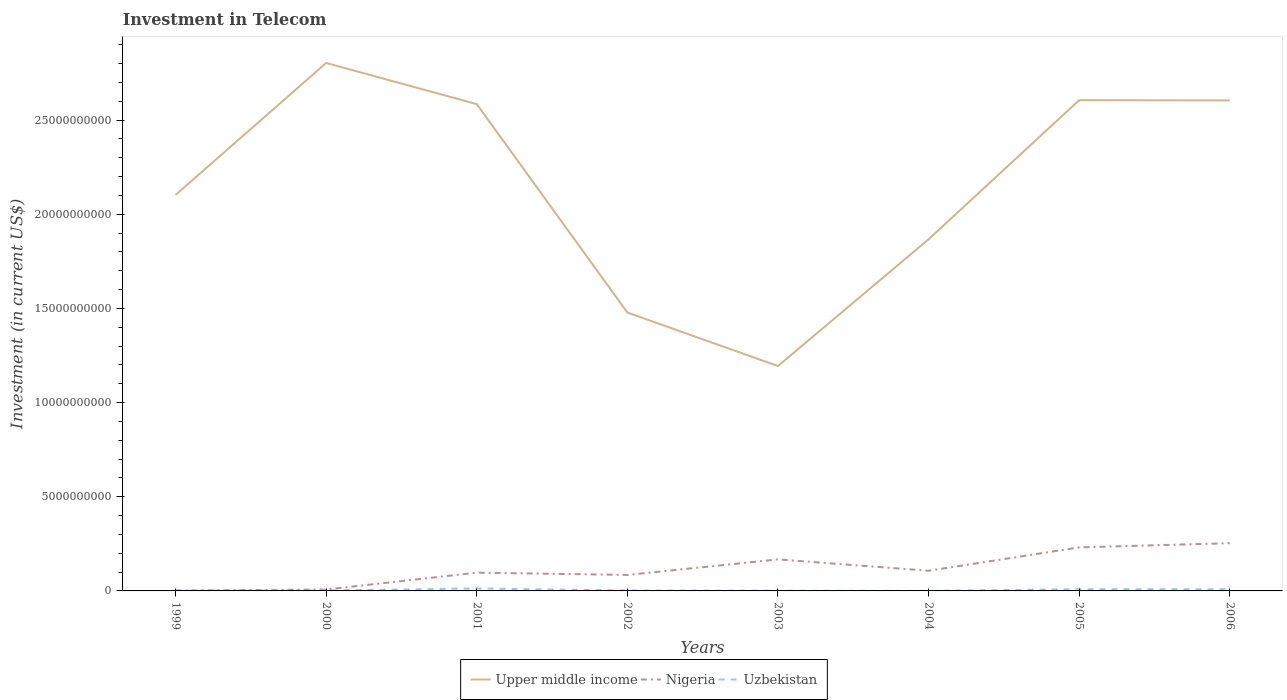How many different coloured lines are there?
Give a very brief answer. 3. Does the line corresponding to Upper middle income intersect with the line corresponding to Nigeria?
Your answer should be very brief. No. Is the number of lines equal to the number of legend labels?
Provide a short and direct response. Yes. Across all years, what is the maximum amount invested in telecom in Uzbekistan?
Offer a very short reply. 3.00e+06. What is the total amount invested in telecom in Upper middle income in the graph?
Your answer should be very brief. -4.82e+09. What is the difference between the highest and the second highest amount invested in telecom in Nigeria?
Keep it short and to the point. 2.52e+09. What is the difference between the highest and the lowest amount invested in telecom in Upper middle income?
Offer a very short reply. 4. Is the amount invested in telecom in Nigeria strictly greater than the amount invested in telecom in Upper middle income over the years?
Make the answer very short. Yes. How many lines are there?
Keep it short and to the point. 3. How many years are there in the graph?
Keep it short and to the point. 8. What is the difference between two consecutive major ticks on the Y-axis?
Give a very brief answer. 5.00e+09. Are the values on the major ticks of Y-axis written in scientific E-notation?
Keep it short and to the point. No. Does the graph contain any zero values?
Provide a succinct answer. No. How are the legend labels stacked?
Give a very brief answer. Horizontal. What is the title of the graph?
Offer a terse response. Investment in Telecom. Does "Vietnam" appear as one of the legend labels in the graph?
Give a very brief answer. No. What is the label or title of the Y-axis?
Provide a succinct answer. Investment (in current US$). What is the Investment (in current US$) of Upper middle income in 1999?
Your answer should be compact. 2.10e+1. What is the Investment (in current US$) in Nigeria in 1999?
Give a very brief answer. 1.90e+07. What is the Investment (in current US$) in Uzbekistan in 1999?
Provide a succinct answer. 1.32e+07. What is the Investment (in current US$) of Upper middle income in 2000?
Your answer should be compact. 2.80e+1. What is the Investment (in current US$) of Nigeria in 2000?
Your response must be concise. 7.57e+07. What is the Investment (in current US$) in Uzbekistan in 2000?
Offer a very short reply. 2.62e+07. What is the Investment (in current US$) of Upper middle income in 2001?
Offer a very short reply. 2.58e+1. What is the Investment (in current US$) in Nigeria in 2001?
Provide a succinct answer. 9.70e+08. What is the Investment (in current US$) in Uzbekistan in 2001?
Your response must be concise. 1.30e+08. What is the Investment (in current US$) in Upper middle income in 2002?
Give a very brief answer. 1.48e+1. What is the Investment (in current US$) in Nigeria in 2002?
Provide a succinct answer. 8.48e+08. What is the Investment (in current US$) of Uzbekistan in 2002?
Your answer should be very brief. 2.32e+07. What is the Investment (in current US$) in Upper middle income in 2003?
Make the answer very short. 1.19e+1. What is the Investment (in current US$) in Nigeria in 2003?
Your answer should be compact. 1.67e+09. What is the Investment (in current US$) of Upper middle income in 2004?
Offer a terse response. 1.87e+1. What is the Investment (in current US$) in Nigeria in 2004?
Your answer should be compact. 1.07e+09. What is the Investment (in current US$) in Uzbekistan in 2004?
Your response must be concise. 3.00e+06. What is the Investment (in current US$) of Upper middle income in 2005?
Make the answer very short. 2.61e+1. What is the Investment (in current US$) of Nigeria in 2005?
Provide a short and direct response. 2.31e+09. What is the Investment (in current US$) in Uzbekistan in 2005?
Provide a succinct answer. 9.30e+07. What is the Investment (in current US$) in Upper middle income in 2006?
Provide a succinct answer. 2.60e+1. What is the Investment (in current US$) in Nigeria in 2006?
Your answer should be very brief. 2.54e+09. What is the Investment (in current US$) in Uzbekistan in 2006?
Offer a terse response. 9.00e+07. Across all years, what is the maximum Investment (in current US$) in Upper middle income?
Provide a short and direct response. 2.80e+1. Across all years, what is the maximum Investment (in current US$) in Nigeria?
Keep it short and to the point. 2.54e+09. Across all years, what is the maximum Investment (in current US$) in Uzbekistan?
Make the answer very short. 1.30e+08. Across all years, what is the minimum Investment (in current US$) in Upper middle income?
Your response must be concise. 1.19e+1. Across all years, what is the minimum Investment (in current US$) of Nigeria?
Make the answer very short. 1.90e+07. What is the total Investment (in current US$) of Upper middle income in the graph?
Keep it short and to the point. 1.72e+11. What is the total Investment (in current US$) in Nigeria in the graph?
Offer a terse response. 9.50e+09. What is the total Investment (in current US$) in Uzbekistan in the graph?
Ensure brevity in your answer.  3.89e+08. What is the difference between the Investment (in current US$) of Upper middle income in 1999 and that in 2000?
Offer a terse response. -7.00e+09. What is the difference between the Investment (in current US$) of Nigeria in 1999 and that in 2000?
Give a very brief answer. -5.67e+07. What is the difference between the Investment (in current US$) of Uzbekistan in 1999 and that in 2000?
Provide a succinct answer. -1.30e+07. What is the difference between the Investment (in current US$) in Upper middle income in 1999 and that in 2001?
Offer a terse response. -4.82e+09. What is the difference between the Investment (in current US$) in Nigeria in 1999 and that in 2001?
Ensure brevity in your answer.  -9.51e+08. What is the difference between the Investment (in current US$) in Uzbekistan in 1999 and that in 2001?
Provide a succinct answer. -1.17e+08. What is the difference between the Investment (in current US$) in Upper middle income in 1999 and that in 2002?
Your answer should be very brief. 6.25e+09. What is the difference between the Investment (in current US$) in Nigeria in 1999 and that in 2002?
Your answer should be compact. -8.29e+08. What is the difference between the Investment (in current US$) of Uzbekistan in 1999 and that in 2002?
Give a very brief answer. -1.00e+07. What is the difference between the Investment (in current US$) in Upper middle income in 1999 and that in 2003?
Provide a short and direct response. 9.09e+09. What is the difference between the Investment (in current US$) in Nigeria in 1999 and that in 2003?
Your answer should be very brief. -1.66e+09. What is the difference between the Investment (in current US$) of Uzbekistan in 1999 and that in 2003?
Provide a succinct answer. 3.20e+06. What is the difference between the Investment (in current US$) of Upper middle income in 1999 and that in 2004?
Your response must be concise. 2.36e+09. What is the difference between the Investment (in current US$) of Nigeria in 1999 and that in 2004?
Offer a very short reply. -1.05e+09. What is the difference between the Investment (in current US$) of Uzbekistan in 1999 and that in 2004?
Offer a very short reply. 1.02e+07. What is the difference between the Investment (in current US$) of Upper middle income in 1999 and that in 2005?
Provide a short and direct response. -5.03e+09. What is the difference between the Investment (in current US$) in Nigeria in 1999 and that in 2005?
Offer a very short reply. -2.29e+09. What is the difference between the Investment (in current US$) of Uzbekistan in 1999 and that in 2005?
Make the answer very short. -7.98e+07. What is the difference between the Investment (in current US$) of Upper middle income in 1999 and that in 2006?
Your answer should be very brief. -5.02e+09. What is the difference between the Investment (in current US$) in Nigeria in 1999 and that in 2006?
Ensure brevity in your answer.  -2.52e+09. What is the difference between the Investment (in current US$) of Uzbekistan in 1999 and that in 2006?
Provide a short and direct response. -7.68e+07. What is the difference between the Investment (in current US$) in Upper middle income in 2000 and that in 2001?
Provide a succinct answer. 2.18e+09. What is the difference between the Investment (in current US$) of Nigeria in 2000 and that in 2001?
Make the answer very short. -8.94e+08. What is the difference between the Investment (in current US$) in Uzbekistan in 2000 and that in 2001?
Provide a short and direct response. -1.04e+08. What is the difference between the Investment (in current US$) of Upper middle income in 2000 and that in 2002?
Make the answer very short. 1.33e+1. What is the difference between the Investment (in current US$) of Nigeria in 2000 and that in 2002?
Make the answer very short. -7.72e+08. What is the difference between the Investment (in current US$) of Upper middle income in 2000 and that in 2003?
Offer a very short reply. 1.61e+1. What is the difference between the Investment (in current US$) in Nigeria in 2000 and that in 2003?
Your response must be concise. -1.60e+09. What is the difference between the Investment (in current US$) of Uzbekistan in 2000 and that in 2003?
Offer a terse response. 1.62e+07. What is the difference between the Investment (in current US$) in Upper middle income in 2000 and that in 2004?
Keep it short and to the point. 9.36e+09. What is the difference between the Investment (in current US$) in Nigeria in 2000 and that in 2004?
Offer a very short reply. -9.94e+08. What is the difference between the Investment (in current US$) in Uzbekistan in 2000 and that in 2004?
Your answer should be compact. 2.32e+07. What is the difference between the Investment (in current US$) of Upper middle income in 2000 and that in 2005?
Offer a very short reply. 1.98e+09. What is the difference between the Investment (in current US$) of Nigeria in 2000 and that in 2005?
Your response must be concise. -2.24e+09. What is the difference between the Investment (in current US$) in Uzbekistan in 2000 and that in 2005?
Make the answer very short. -6.68e+07. What is the difference between the Investment (in current US$) of Upper middle income in 2000 and that in 2006?
Offer a terse response. 1.99e+09. What is the difference between the Investment (in current US$) of Nigeria in 2000 and that in 2006?
Make the answer very short. -2.46e+09. What is the difference between the Investment (in current US$) in Uzbekistan in 2000 and that in 2006?
Your answer should be compact. -6.38e+07. What is the difference between the Investment (in current US$) of Upper middle income in 2001 and that in 2002?
Your answer should be very brief. 1.11e+1. What is the difference between the Investment (in current US$) in Nigeria in 2001 and that in 2002?
Your answer should be very brief. 1.22e+08. What is the difference between the Investment (in current US$) of Uzbekistan in 2001 and that in 2002?
Ensure brevity in your answer.  1.07e+08. What is the difference between the Investment (in current US$) of Upper middle income in 2001 and that in 2003?
Your answer should be compact. 1.39e+1. What is the difference between the Investment (in current US$) of Nigeria in 2001 and that in 2003?
Offer a terse response. -7.04e+08. What is the difference between the Investment (in current US$) in Uzbekistan in 2001 and that in 2003?
Keep it short and to the point. 1.20e+08. What is the difference between the Investment (in current US$) of Upper middle income in 2001 and that in 2004?
Give a very brief answer. 7.18e+09. What is the difference between the Investment (in current US$) of Nigeria in 2001 and that in 2004?
Your answer should be compact. -1.00e+08. What is the difference between the Investment (in current US$) in Uzbekistan in 2001 and that in 2004?
Offer a very short reply. 1.27e+08. What is the difference between the Investment (in current US$) in Upper middle income in 2001 and that in 2005?
Offer a terse response. -2.09e+08. What is the difference between the Investment (in current US$) of Nigeria in 2001 and that in 2005?
Keep it short and to the point. -1.34e+09. What is the difference between the Investment (in current US$) in Uzbekistan in 2001 and that in 2005?
Provide a succinct answer. 3.72e+07. What is the difference between the Investment (in current US$) of Upper middle income in 2001 and that in 2006?
Keep it short and to the point. -1.96e+08. What is the difference between the Investment (in current US$) in Nigeria in 2001 and that in 2006?
Your answer should be compact. -1.57e+09. What is the difference between the Investment (in current US$) in Uzbekistan in 2001 and that in 2006?
Your answer should be compact. 4.02e+07. What is the difference between the Investment (in current US$) of Upper middle income in 2002 and that in 2003?
Your answer should be compact. 2.84e+09. What is the difference between the Investment (in current US$) in Nigeria in 2002 and that in 2003?
Your answer should be very brief. -8.26e+08. What is the difference between the Investment (in current US$) in Uzbekistan in 2002 and that in 2003?
Your answer should be very brief. 1.32e+07. What is the difference between the Investment (in current US$) of Upper middle income in 2002 and that in 2004?
Your response must be concise. -3.89e+09. What is the difference between the Investment (in current US$) in Nigeria in 2002 and that in 2004?
Your answer should be compact. -2.22e+08. What is the difference between the Investment (in current US$) in Uzbekistan in 2002 and that in 2004?
Give a very brief answer. 2.02e+07. What is the difference between the Investment (in current US$) of Upper middle income in 2002 and that in 2005?
Your response must be concise. -1.13e+1. What is the difference between the Investment (in current US$) in Nigeria in 2002 and that in 2005?
Your response must be concise. -1.46e+09. What is the difference between the Investment (in current US$) of Uzbekistan in 2002 and that in 2005?
Your response must be concise. -6.98e+07. What is the difference between the Investment (in current US$) of Upper middle income in 2002 and that in 2006?
Your answer should be very brief. -1.13e+1. What is the difference between the Investment (in current US$) of Nigeria in 2002 and that in 2006?
Ensure brevity in your answer.  -1.69e+09. What is the difference between the Investment (in current US$) in Uzbekistan in 2002 and that in 2006?
Make the answer very short. -6.68e+07. What is the difference between the Investment (in current US$) in Upper middle income in 2003 and that in 2004?
Your response must be concise. -6.73e+09. What is the difference between the Investment (in current US$) in Nigeria in 2003 and that in 2004?
Keep it short and to the point. 6.04e+08. What is the difference between the Investment (in current US$) in Uzbekistan in 2003 and that in 2004?
Your response must be concise. 7.00e+06. What is the difference between the Investment (in current US$) in Upper middle income in 2003 and that in 2005?
Offer a very short reply. -1.41e+1. What is the difference between the Investment (in current US$) in Nigeria in 2003 and that in 2005?
Give a very brief answer. -6.38e+08. What is the difference between the Investment (in current US$) of Uzbekistan in 2003 and that in 2005?
Make the answer very short. -8.30e+07. What is the difference between the Investment (in current US$) in Upper middle income in 2003 and that in 2006?
Offer a very short reply. -1.41e+1. What is the difference between the Investment (in current US$) in Nigeria in 2003 and that in 2006?
Your answer should be compact. -8.61e+08. What is the difference between the Investment (in current US$) in Uzbekistan in 2003 and that in 2006?
Offer a very short reply. -8.00e+07. What is the difference between the Investment (in current US$) of Upper middle income in 2004 and that in 2005?
Keep it short and to the point. -7.39e+09. What is the difference between the Investment (in current US$) of Nigeria in 2004 and that in 2005?
Provide a succinct answer. -1.24e+09. What is the difference between the Investment (in current US$) of Uzbekistan in 2004 and that in 2005?
Your response must be concise. -9.00e+07. What is the difference between the Investment (in current US$) in Upper middle income in 2004 and that in 2006?
Offer a very short reply. -7.37e+09. What is the difference between the Investment (in current US$) of Nigeria in 2004 and that in 2006?
Ensure brevity in your answer.  -1.47e+09. What is the difference between the Investment (in current US$) in Uzbekistan in 2004 and that in 2006?
Provide a short and direct response. -8.70e+07. What is the difference between the Investment (in current US$) in Upper middle income in 2005 and that in 2006?
Keep it short and to the point. 1.27e+07. What is the difference between the Investment (in current US$) of Nigeria in 2005 and that in 2006?
Provide a short and direct response. -2.23e+08. What is the difference between the Investment (in current US$) of Uzbekistan in 2005 and that in 2006?
Ensure brevity in your answer.  3.00e+06. What is the difference between the Investment (in current US$) in Upper middle income in 1999 and the Investment (in current US$) in Nigeria in 2000?
Your answer should be very brief. 2.10e+1. What is the difference between the Investment (in current US$) in Upper middle income in 1999 and the Investment (in current US$) in Uzbekistan in 2000?
Make the answer very short. 2.10e+1. What is the difference between the Investment (in current US$) in Nigeria in 1999 and the Investment (in current US$) in Uzbekistan in 2000?
Offer a very short reply. -7.20e+06. What is the difference between the Investment (in current US$) of Upper middle income in 1999 and the Investment (in current US$) of Nigeria in 2001?
Your answer should be very brief. 2.01e+1. What is the difference between the Investment (in current US$) in Upper middle income in 1999 and the Investment (in current US$) in Uzbekistan in 2001?
Ensure brevity in your answer.  2.09e+1. What is the difference between the Investment (in current US$) of Nigeria in 1999 and the Investment (in current US$) of Uzbekistan in 2001?
Provide a succinct answer. -1.11e+08. What is the difference between the Investment (in current US$) of Upper middle income in 1999 and the Investment (in current US$) of Nigeria in 2002?
Give a very brief answer. 2.02e+1. What is the difference between the Investment (in current US$) in Upper middle income in 1999 and the Investment (in current US$) in Uzbekistan in 2002?
Your answer should be very brief. 2.10e+1. What is the difference between the Investment (in current US$) of Nigeria in 1999 and the Investment (in current US$) of Uzbekistan in 2002?
Give a very brief answer. -4.20e+06. What is the difference between the Investment (in current US$) in Upper middle income in 1999 and the Investment (in current US$) in Nigeria in 2003?
Your response must be concise. 1.94e+1. What is the difference between the Investment (in current US$) in Upper middle income in 1999 and the Investment (in current US$) in Uzbekistan in 2003?
Offer a very short reply. 2.10e+1. What is the difference between the Investment (in current US$) in Nigeria in 1999 and the Investment (in current US$) in Uzbekistan in 2003?
Make the answer very short. 9.00e+06. What is the difference between the Investment (in current US$) of Upper middle income in 1999 and the Investment (in current US$) of Nigeria in 2004?
Give a very brief answer. 2.00e+1. What is the difference between the Investment (in current US$) of Upper middle income in 1999 and the Investment (in current US$) of Uzbekistan in 2004?
Provide a succinct answer. 2.10e+1. What is the difference between the Investment (in current US$) of Nigeria in 1999 and the Investment (in current US$) of Uzbekistan in 2004?
Make the answer very short. 1.60e+07. What is the difference between the Investment (in current US$) of Upper middle income in 1999 and the Investment (in current US$) of Nigeria in 2005?
Provide a succinct answer. 1.87e+1. What is the difference between the Investment (in current US$) of Upper middle income in 1999 and the Investment (in current US$) of Uzbekistan in 2005?
Offer a terse response. 2.09e+1. What is the difference between the Investment (in current US$) in Nigeria in 1999 and the Investment (in current US$) in Uzbekistan in 2005?
Your response must be concise. -7.40e+07. What is the difference between the Investment (in current US$) in Upper middle income in 1999 and the Investment (in current US$) in Nigeria in 2006?
Make the answer very short. 1.85e+1. What is the difference between the Investment (in current US$) in Upper middle income in 1999 and the Investment (in current US$) in Uzbekistan in 2006?
Offer a terse response. 2.09e+1. What is the difference between the Investment (in current US$) in Nigeria in 1999 and the Investment (in current US$) in Uzbekistan in 2006?
Offer a very short reply. -7.10e+07. What is the difference between the Investment (in current US$) in Upper middle income in 2000 and the Investment (in current US$) in Nigeria in 2001?
Your answer should be very brief. 2.71e+1. What is the difference between the Investment (in current US$) of Upper middle income in 2000 and the Investment (in current US$) of Uzbekistan in 2001?
Offer a terse response. 2.79e+1. What is the difference between the Investment (in current US$) in Nigeria in 2000 and the Investment (in current US$) in Uzbekistan in 2001?
Provide a succinct answer. -5.45e+07. What is the difference between the Investment (in current US$) in Upper middle income in 2000 and the Investment (in current US$) in Nigeria in 2002?
Keep it short and to the point. 2.72e+1. What is the difference between the Investment (in current US$) of Upper middle income in 2000 and the Investment (in current US$) of Uzbekistan in 2002?
Provide a short and direct response. 2.80e+1. What is the difference between the Investment (in current US$) in Nigeria in 2000 and the Investment (in current US$) in Uzbekistan in 2002?
Make the answer very short. 5.25e+07. What is the difference between the Investment (in current US$) of Upper middle income in 2000 and the Investment (in current US$) of Nigeria in 2003?
Give a very brief answer. 2.64e+1. What is the difference between the Investment (in current US$) in Upper middle income in 2000 and the Investment (in current US$) in Uzbekistan in 2003?
Keep it short and to the point. 2.80e+1. What is the difference between the Investment (in current US$) of Nigeria in 2000 and the Investment (in current US$) of Uzbekistan in 2003?
Your response must be concise. 6.57e+07. What is the difference between the Investment (in current US$) of Upper middle income in 2000 and the Investment (in current US$) of Nigeria in 2004?
Ensure brevity in your answer.  2.70e+1. What is the difference between the Investment (in current US$) in Upper middle income in 2000 and the Investment (in current US$) in Uzbekistan in 2004?
Your answer should be compact. 2.80e+1. What is the difference between the Investment (in current US$) in Nigeria in 2000 and the Investment (in current US$) in Uzbekistan in 2004?
Offer a terse response. 7.27e+07. What is the difference between the Investment (in current US$) of Upper middle income in 2000 and the Investment (in current US$) of Nigeria in 2005?
Give a very brief answer. 2.57e+1. What is the difference between the Investment (in current US$) in Upper middle income in 2000 and the Investment (in current US$) in Uzbekistan in 2005?
Your answer should be compact. 2.79e+1. What is the difference between the Investment (in current US$) in Nigeria in 2000 and the Investment (in current US$) in Uzbekistan in 2005?
Ensure brevity in your answer.  -1.73e+07. What is the difference between the Investment (in current US$) of Upper middle income in 2000 and the Investment (in current US$) of Nigeria in 2006?
Offer a terse response. 2.55e+1. What is the difference between the Investment (in current US$) in Upper middle income in 2000 and the Investment (in current US$) in Uzbekistan in 2006?
Your answer should be compact. 2.79e+1. What is the difference between the Investment (in current US$) of Nigeria in 2000 and the Investment (in current US$) of Uzbekistan in 2006?
Your response must be concise. -1.43e+07. What is the difference between the Investment (in current US$) of Upper middle income in 2001 and the Investment (in current US$) of Nigeria in 2002?
Give a very brief answer. 2.50e+1. What is the difference between the Investment (in current US$) in Upper middle income in 2001 and the Investment (in current US$) in Uzbekistan in 2002?
Offer a terse response. 2.58e+1. What is the difference between the Investment (in current US$) of Nigeria in 2001 and the Investment (in current US$) of Uzbekistan in 2002?
Ensure brevity in your answer.  9.47e+08. What is the difference between the Investment (in current US$) of Upper middle income in 2001 and the Investment (in current US$) of Nigeria in 2003?
Your answer should be compact. 2.42e+1. What is the difference between the Investment (in current US$) of Upper middle income in 2001 and the Investment (in current US$) of Uzbekistan in 2003?
Your answer should be compact. 2.58e+1. What is the difference between the Investment (in current US$) of Nigeria in 2001 and the Investment (in current US$) of Uzbekistan in 2003?
Offer a very short reply. 9.60e+08. What is the difference between the Investment (in current US$) in Upper middle income in 2001 and the Investment (in current US$) in Nigeria in 2004?
Offer a terse response. 2.48e+1. What is the difference between the Investment (in current US$) in Upper middle income in 2001 and the Investment (in current US$) in Uzbekistan in 2004?
Offer a very short reply. 2.58e+1. What is the difference between the Investment (in current US$) in Nigeria in 2001 and the Investment (in current US$) in Uzbekistan in 2004?
Make the answer very short. 9.67e+08. What is the difference between the Investment (in current US$) of Upper middle income in 2001 and the Investment (in current US$) of Nigeria in 2005?
Your response must be concise. 2.35e+1. What is the difference between the Investment (in current US$) of Upper middle income in 2001 and the Investment (in current US$) of Uzbekistan in 2005?
Your response must be concise. 2.58e+1. What is the difference between the Investment (in current US$) in Nigeria in 2001 and the Investment (in current US$) in Uzbekistan in 2005?
Offer a terse response. 8.77e+08. What is the difference between the Investment (in current US$) in Upper middle income in 2001 and the Investment (in current US$) in Nigeria in 2006?
Your answer should be compact. 2.33e+1. What is the difference between the Investment (in current US$) in Upper middle income in 2001 and the Investment (in current US$) in Uzbekistan in 2006?
Your response must be concise. 2.58e+1. What is the difference between the Investment (in current US$) of Nigeria in 2001 and the Investment (in current US$) of Uzbekistan in 2006?
Your response must be concise. 8.80e+08. What is the difference between the Investment (in current US$) in Upper middle income in 2002 and the Investment (in current US$) in Nigeria in 2003?
Offer a terse response. 1.31e+1. What is the difference between the Investment (in current US$) of Upper middle income in 2002 and the Investment (in current US$) of Uzbekistan in 2003?
Your answer should be very brief. 1.48e+1. What is the difference between the Investment (in current US$) of Nigeria in 2002 and the Investment (in current US$) of Uzbekistan in 2003?
Keep it short and to the point. 8.38e+08. What is the difference between the Investment (in current US$) of Upper middle income in 2002 and the Investment (in current US$) of Nigeria in 2004?
Offer a terse response. 1.37e+1. What is the difference between the Investment (in current US$) of Upper middle income in 2002 and the Investment (in current US$) of Uzbekistan in 2004?
Keep it short and to the point. 1.48e+1. What is the difference between the Investment (in current US$) in Nigeria in 2002 and the Investment (in current US$) in Uzbekistan in 2004?
Give a very brief answer. 8.45e+08. What is the difference between the Investment (in current US$) of Upper middle income in 2002 and the Investment (in current US$) of Nigeria in 2005?
Keep it short and to the point. 1.25e+1. What is the difference between the Investment (in current US$) in Upper middle income in 2002 and the Investment (in current US$) in Uzbekistan in 2005?
Make the answer very short. 1.47e+1. What is the difference between the Investment (in current US$) in Nigeria in 2002 and the Investment (in current US$) in Uzbekistan in 2005?
Your answer should be very brief. 7.55e+08. What is the difference between the Investment (in current US$) in Upper middle income in 2002 and the Investment (in current US$) in Nigeria in 2006?
Provide a succinct answer. 1.22e+1. What is the difference between the Investment (in current US$) of Upper middle income in 2002 and the Investment (in current US$) of Uzbekistan in 2006?
Your answer should be compact. 1.47e+1. What is the difference between the Investment (in current US$) in Nigeria in 2002 and the Investment (in current US$) in Uzbekistan in 2006?
Give a very brief answer. 7.58e+08. What is the difference between the Investment (in current US$) of Upper middle income in 2003 and the Investment (in current US$) of Nigeria in 2004?
Provide a short and direct response. 1.09e+1. What is the difference between the Investment (in current US$) of Upper middle income in 2003 and the Investment (in current US$) of Uzbekistan in 2004?
Keep it short and to the point. 1.19e+1. What is the difference between the Investment (in current US$) of Nigeria in 2003 and the Investment (in current US$) of Uzbekistan in 2004?
Offer a terse response. 1.67e+09. What is the difference between the Investment (in current US$) of Upper middle income in 2003 and the Investment (in current US$) of Nigeria in 2005?
Your response must be concise. 9.63e+09. What is the difference between the Investment (in current US$) of Upper middle income in 2003 and the Investment (in current US$) of Uzbekistan in 2005?
Your response must be concise. 1.18e+1. What is the difference between the Investment (in current US$) of Nigeria in 2003 and the Investment (in current US$) of Uzbekistan in 2005?
Offer a very short reply. 1.58e+09. What is the difference between the Investment (in current US$) of Upper middle income in 2003 and the Investment (in current US$) of Nigeria in 2006?
Your answer should be compact. 9.41e+09. What is the difference between the Investment (in current US$) in Upper middle income in 2003 and the Investment (in current US$) in Uzbekistan in 2006?
Provide a short and direct response. 1.19e+1. What is the difference between the Investment (in current US$) of Nigeria in 2003 and the Investment (in current US$) of Uzbekistan in 2006?
Ensure brevity in your answer.  1.58e+09. What is the difference between the Investment (in current US$) of Upper middle income in 2004 and the Investment (in current US$) of Nigeria in 2005?
Provide a short and direct response. 1.64e+1. What is the difference between the Investment (in current US$) of Upper middle income in 2004 and the Investment (in current US$) of Uzbekistan in 2005?
Make the answer very short. 1.86e+1. What is the difference between the Investment (in current US$) in Nigeria in 2004 and the Investment (in current US$) in Uzbekistan in 2005?
Your answer should be compact. 9.77e+08. What is the difference between the Investment (in current US$) of Upper middle income in 2004 and the Investment (in current US$) of Nigeria in 2006?
Your answer should be very brief. 1.61e+1. What is the difference between the Investment (in current US$) in Upper middle income in 2004 and the Investment (in current US$) in Uzbekistan in 2006?
Keep it short and to the point. 1.86e+1. What is the difference between the Investment (in current US$) in Nigeria in 2004 and the Investment (in current US$) in Uzbekistan in 2006?
Provide a short and direct response. 9.80e+08. What is the difference between the Investment (in current US$) of Upper middle income in 2005 and the Investment (in current US$) of Nigeria in 2006?
Keep it short and to the point. 2.35e+1. What is the difference between the Investment (in current US$) in Upper middle income in 2005 and the Investment (in current US$) in Uzbekistan in 2006?
Your answer should be compact. 2.60e+1. What is the difference between the Investment (in current US$) of Nigeria in 2005 and the Investment (in current US$) of Uzbekistan in 2006?
Ensure brevity in your answer.  2.22e+09. What is the average Investment (in current US$) of Upper middle income per year?
Give a very brief answer. 2.15e+1. What is the average Investment (in current US$) of Nigeria per year?
Your answer should be very brief. 1.19e+09. What is the average Investment (in current US$) in Uzbekistan per year?
Keep it short and to the point. 4.86e+07. In the year 1999, what is the difference between the Investment (in current US$) in Upper middle income and Investment (in current US$) in Nigeria?
Make the answer very short. 2.10e+1. In the year 1999, what is the difference between the Investment (in current US$) in Upper middle income and Investment (in current US$) in Uzbekistan?
Offer a very short reply. 2.10e+1. In the year 1999, what is the difference between the Investment (in current US$) in Nigeria and Investment (in current US$) in Uzbekistan?
Offer a very short reply. 5.80e+06. In the year 2000, what is the difference between the Investment (in current US$) of Upper middle income and Investment (in current US$) of Nigeria?
Your answer should be very brief. 2.80e+1. In the year 2000, what is the difference between the Investment (in current US$) in Upper middle income and Investment (in current US$) in Uzbekistan?
Provide a short and direct response. 2.80e+1. In the year 2000, what is the difference between the Investment (in current US$) in Nigeria and Investment (in current US$) in Uzbekistan?
Make the answer very short. 4.95e+07. In the year 2001, what is the difference between the Investment (in current US$) of Upper middle income and Investment (in current US$) of Nigeria?
Provide a succinct answer. 2.49e+1. In the year 2001, what is the difference between the Investment (in current US$) in Upper middle income and Investment (in current US$) in Uzbekistan?
Offer a very short reply. 2.57e+1. In the year 2001, what is the difference between the Investment (in current US$) of Nigeria and Investment (in current US$) of Uzbekistan?
Your response must be concise. 8.40e+08. In the year 2002, what is the difference between the Investment (in current US$) in Upper middle income and Investment (in current US$) in Nigeria?
Ensure brevity in your answer.  1.39e+1. In the year 2002, what is the difference between the Investment (in current US$) in Upper middle income and Investment (in current US$) in Uzbekistan?
Keep it short and to the point. 1.48e+1. In the year 2002, what is the difference between the Investment (in current US$) of Nigeria and Investment (in current US$) of Uzbekistan?
Ensure brevity in your answer.  8.25e+08. In the year 2003, what is the difference between the Investment (in current US$) in Upper middle income and Investment (in current US$) in Nigeria?
Ensure brevity in your answer.  1.03e+1. In the year 2003, what is the difference between the Investment (in current US$) of Upper middle income and Investment (in current US$) of Uzbekistan?
Make the answer very short. 1.19e+1. In the year 2003, what is the difference between the Investment (in current US$) in Nigeria and Investment (in current US$) in Uzbekistan?
Your response must be concise. 1.66e+09. In the year 2004, what is the difference between the Investment (in current US$) in Upper middle income and Investment (in current US$) in Nigeria?
Provide a short and direct response. 1.76e+1. In the year 2004, what is the difference between the Investment (in current US$) in Upper middle income and Investment (in current US$) in Uzbekistan?
Provide a short and direct response. 1.87e+1. In the year 2004, what is the difference between the Investment (in current US$) of Nigeria and Investment (in current US$) of Uzbekistan?
Give a very brief answer. 1.07e+09. In the year 2005, what is the difference between the Investment (in current US$) in Upper middle income and Investment (in current US$) in Nigeria?
Offer a terse response. 2.37e+1. In the year 2005, what is the difference between the Investment (in current US$) of Upper middle income and Investment (in current US$) of Uzbekistan?
Keep it short and to the point. 2.60e+1. In the year 2005, what is the difference between the Investment (in current US$) in Nigeria and Investment (in current US$) in Uzbekistan?
Your answer should be compact. 2.22e+09. In the year 2006, what is the difference between the Investment (in current US$) in Upper middle income and Investment (in current US$) in Nigeria?
Your response must be concise. 2.35e+1. In the year 2006, what is the difference between the Investment (in current US$) in Upper middle income and Investment (in current US$) in Uzbekistan?
Provide a short and direct response. 2.60e+1. In the year 2006, what is the difference between the Investment (in current US$) of Nigeria and Investment (in current US$) of Uzbekistan?
Your answer should be compact. 2.45e+09. What is the ratio of the Investment (in current US$) of Upper middle income in 1999 to that in 2000?
Your answer should be compact. 0.75. What is the ratio of the Investment (in current US$) of Nigeria in 1999 to that in 2000?
Your response must be concise. 0.25. What is the ratio of the Investment (in current US$) in Uzbekistan in 1999 to that in 2000?
Offer a very short reply. 0.5. What is the ratio of the Investment (in current US$) of Upper middle income in 1999 to that in 2001?
Your response must be concise. 0.81. What is the ratio of the Investment (in current US$) in Nigeria in 1999 to that in 2001?
Provide a short and direct response. 0.02. What is the ratio of the Investment (in current US$) of Uzbekistan in 1999 to that in 2001?
Provide a short and direct response. 0.1. What is the ratio of the Investment (in current US$) of Upper middle income in 1999 to that in 2002?
Your answer should be compact. 1.42. What is the ratio of the Investment (in current US$) of Nigeria in 1999 to that in 2002?
Give a very brief answer. 0.02. What is the ratio of the Investment (in current US$) of Uzbekistan in 1999 to that in 2002?
Ensure brevity in your answer.  0.57. What is the ratio of the Investment (in current US$) in Upper middle income in 1999 to that in 2003?
Ensure brevity in your answer.  1.76. What is the ratio of the Investment (in current US$) of Nigeria in 1999 to that in 2003?
Your response must be concise. 0.01. What is the ratio of the Investment (in current US$) of Uzbekistan in 1999 to that in 2003?
Your answer should be compact. 1.32. What is the ratio of the Investment (in current US$) of Upper middle income in 1999 to that in 2004?
Give a very brief answer. 1.13. What is the ratio of the Investment (in current US$) in Nigeria in 1999 to that in 2004?
Your answer should be compact. 0.02. What is the ratio of the Investment (in current US$) in Upper middle income in 1999 to that in 2005?
Your answer should be very brief. 0.81. What is the ratio of the Investment (in current US$) in Nigeria in 1999 to that in 2005?
Provide a short and direct response. 0.01. What is the ratio of the Investment (in current US$) of Uzbekistan in 1999 to that in 2005?
Your answer should be very brief. 0.14. What is the ratio of the Investment (in current US$) in Upper middle income in 1999 to that in 2006?
Provide a short and direct response. 0.81. What is the ratio of the Investment (in current US$) of Nigeria in 1999 to that in 2006?
Make the answer very short. 0.01. What is the ratio of the Investment (in current US$) of Uzbekistan in 1999 to that in 2006?
Ensure brevity in your answer.  0.15. What is the ratio of the Investment (in current US$) in Upper middle income in 2000 to that in 2001?
Provide a short and direct response. 1.08. What is the ratio of the Investment (in current US$) in Nigeria in 2000 to that in 2001?
Ensure brevity in your answer.  0.08. What is the ratio of the Investment (in current US$) of Uzbekistan in 2000 to that in 2001?
Keep it short and to the point. 0.2. What is the ratio of the Investment (in current US$) of Upper middle income in 2000 to that in 2002?
Make the answer very short. 1.9. What is the ratio of the Investment (in current US$) in Nigeria in 2000 to that in 2002?
Your answer should be very brief. 0.09. What is the ratio of the Investment (in current US$) in Uzbekistan in 2000 to that in 2002?
Your answer should be very brief. 1.13. What is the ratio of the Investment (in current US$) in Upper middle income in 2000 to that in 2003?
Ensure brevity in your answer.  2.35. What is the ratio of the Investment (in current US$) of Nigeria in 2000 to that in 2003?
Provide a succinct answer. 0.05. What is the ratio of the Investment (in current US$) of Uzbekistan in 2000 to that in 2003?
Provide a short and direct response. 2.62. What is the ratio of the Investment (in current US$) of Upper middle income in 2000 to that in 2004?
Ensure brevity in your answer.  1.5. What is the ratio of the Investment (in current US$) of Nigeria in 2000 to that in 2004?
Your answer should be compact. 0.07. What is the ratio of the Investment (in current US$) of Uzbekistan in 2000 to that in 2004?
Give a very brief answer. 8.73. What is the ratio of the Investment (in current US$) of Upper middle income in 2000 to that in 2005?
Provide a short and direct response. 1.08. What is the ratio of the Investment (in current US$) of Nigeria in 2000 to that in 2005?
Your response must be concise. 0.03. What is the ratio of the Investment (in current US$) in Uzbekistan in 2000 to that in 2005?
Your answer should be compact. 0.28. What is the ratio of the Investment (in current US$) in Upper middle income in 2000 to that in 2006?
Keep it short and to the point. 1.08. What is the ratio of the Investment (in current US$) of Nigeria in 2000 to that in 2006?
Provide a succinct answer. 0.03. What is the ratio of the Investment (in current US$) in Uzbekistan in 2000 to that in 2006?
Provide a short and direct response. 0.29. What is the ratio of the Investment (in current US$) in Upper middle income in 2001 to that in 2002?
Make the answer very short. 1.75. What is the ratio of the Investment (in current US$) in Nigeria in 2001 to that in 2002?
Offer a very short reply. 1.14. What is the ratio of the Investment (in current US$) of Uzbekistan in 2001 to that in 2002?
Offer a terse response. 5.61. What is the ratio of the Investment (in current US$) in Upper middle income in 2001 to that in 2003?
Offer a terse response. 2.16. What is the ratio of the Investment (in current US$) of Nigeria in 2001 to that in 2003?
Make the answer very short. 0.58. What is the ratio of the Investment (in current US$) in Uzbekistan in 2001 to that in 2003?
Offer a very short reply. 13.02. What is the ratio of the Investment (in current US$) in Upper middle income in 2001 to that in 2004?
Provide a short and direct response. 1.38. What is the ratio of the Investment (in current US$) in Nigeria in 2001 to that in 2004?
Offer a very short reply. 0.91. What is the ratio of the Investment (in current US$) in Uzbekistan in 2001 to that in 2004?
Keep it short and to the point. 43.4. What is the ratio of the Investment (in current US$) in Upper middle income in 2001 to that in 2005?
Your answer should be very brief. 0.99. What is the ratio of the Investment (in current US$) in Nigeria in 2001 to that in 2005?
Your answer should be compact. 0.42. What is the ratio of the Investment (in current US$) in Nigeria in 2001 to that in 2006?
Ensure brevity in your answer.  0.38. What is the ratio of the Investment (in current US$) of Uzbekistan in 2001 to that in 2006?
Make the answer very short. 1.45. What is the ratio of the Investment (in current US$) in Upper middle income in 2002 to that in 2003?
Your answer should be very brief. 1.24. What is the ratio of the Investment (in current US$) in Nigeria in 2002 to that in 2003?
Your response must be concise. 0.51. What is the ratio of the Investment (in current US$) of Uzbekistan in 2002 to that in 2003?
Make the answer very short. 2.32. What is the ratio of the Investment (in current US$) of Upper middle income in 2002 to that in 2004?
Provide a succinct answer. 0.79. What is the ratio of the Investment (in current US$) in Nigeria in 2002 to that in 2004?
Your answer should be very brief. 0.79. What is the ratio of the Investment (in current US$) in Uzbekistan in 2002 to that in 2004?
Make the answer very short. 7.73. What is the ratio of the Investment (in current US$) in Upper middle income in 2002 to that in 2005?
Your answer should be compact. 0.57. What is the ratio of the Investment (in current US$) in Nigeria in 2002 to that in 2005?
Give a very brief answer. 0.37. What is the ratio of the Investment (in current US$) of Uzbekistan in 2002 to that in 2005?
Give a very brief answer. 0.25. What is the ratio of the Investment (in current US$) of Upper middle income in 2002 to that in 2006?
Offer a very short reply. 0.57. What is the ratio of the Investment (in current US$) in Nigeria in 2002 to that in 2006?
Offer a very short reply. 0.33. What is the ratio of the Investment (in current US$) in Uzbekistan in 2002 to that in 2006?
Ensure brevity in your answer.  0.26. What is the ratio of the Investment (in current US$) of Upper middle income in 2003 to that in 2004?
Keep it short and to the point. 0.64. What is the ratio of the Investment (in current US$) in Nigeria in 2003 to that in 2004?
Your answer should be compact. 1.56. What is the ratio of the Investment (in current US$) in Upper middle income in 2003 to that in 2005?
Offer a very short reply. 0.46. What is the ratio of the Investment (in current US$) of Nigeria in 2003 to that in 2005?
Your answer should be very brief. 0.72. What is the ratio of the Investment (in current US$) of Uzbekistan in 2003 to that in 2005?
Your response must be concise. 0.11. What is the ratio of the Investment (in current US$) in Upper middle income in 2003 to that in 2006?
Offer a very short reply. 0.46. What is the ratio of the Investment (in current US$) in Nigeria in 2003 to that in 2006?
Give a very brief answer. 0.66. What is the ratio of the Investment (in current US$) of Upper middle income in 2004 to that in 2005?
Your response must be concise. 0.72. What is the ratio of the Investment (in current US$) of Nigeria in 2004 to that in 2005?
Your response must be concise. 0.46. What is the ratio of the Investment (in current US$) of Uzbekistan in 2004 to that in 2005?
Your answer should be compact. 0.03. What is the ratio of the Investment (in current US$) in Upper middle income in 2004 to that in 2006?
Your answer should be compact. 0.72. What is the ratio of the Investment (in current US$) of Nigeria in 2004 to that in 2006?
Ensure brevity in your answer.  0.42. What is the ratio of the Investment (in current US$) of Nigeria in 2005 to that in 2006?
Your response must be concise. 0.91. What is the difference between the highest and the second highest Investment (in current US$) of Upper middle income?
Your answer should be compact. 1.98e+09. What is the difference between the highest and the second highest Investment (in current US$) of Nigeria?
Your answer should be compact. 2.23e+08. What is the difference between the highest and the second highest Investment (in current US$) of Uzbekistan?
Your response must be concise. 3.72e+07. What is the difference between the highest and the lowest Investment (in current US$) of Upper middle income?
Provide a short and direct response. 1.61e+1. What is the difference between the highest and the lowest Investment (in current US$) in Nigeria?
Provide a succinct answer. 2.52e+09. What is the difference between the highest and the lowest Investment (in current US$) of Uzbekistan?
Your answer should be compact. 1.27e+08. 